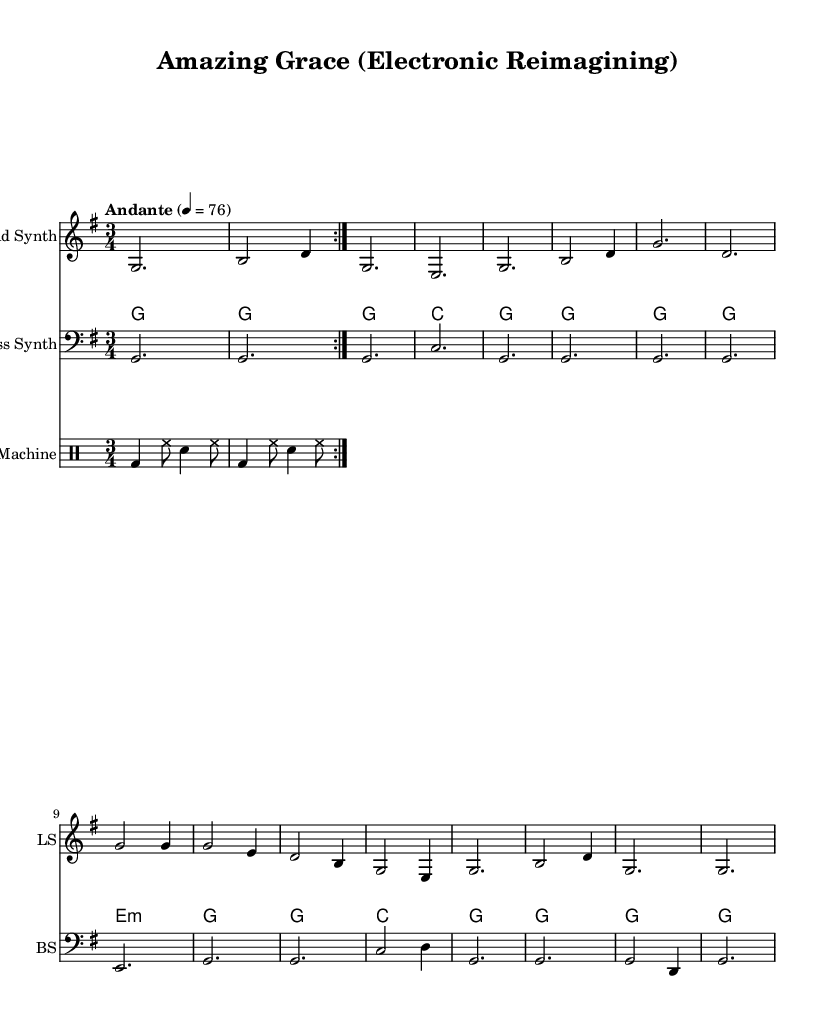What is the key signature of this music? The key signature is G major, which has one sharp (F#). This can be determined by looking at the key signature at the beginning of the staff, which represents the notes that are sharp or flat throughout the piece.
Answer: G major What is the time signature of this music? The time signature is 3/4, indicated at the beginning of the score. It means there are three beats in each measure, and the quarter note gets one beat.
Answer: 3/4 What is the tempo marking for this piece? The tempo marking is "Andante", which typically indicates a moderately slow tempo, roughly around 76 beats per minute. This is specified in the tempo directive at the beginning of the score.
Answer: Andante How many measures are there in the lead synth part? The lead synth part consists of eight measures. By counting the groupings of notes and rests indicated on the staff, you can see that the notes are distributed across eight distinct measures based on the bar lines.
Answer: 8 Which instrument plays the bass line? The bass line is played by the Bass Synth, indicated by the staff labeled "Bass Synth" at the beginning of that section. The design of the staff shows that it is specifically designated for the bass clef, which is used for lower-pitched instruments.
Answer: Bass Synth How many times does the drum machine repeat the pattern? The drum machine repeats the pattern twice, as indicated by the "repeat volta 2" marking. This means the music will be played through the specified pattern two times before continuing.
Answer: 2 What type of harmony is predominantly used in the pad synth section? The pad synth section uses primarily triadic harmonies, indicated by the chord mode entries that follow the structure of triads based on the specified chords. This can be inferred from the use of stacked notes that form chords.
Answer: Triadic 